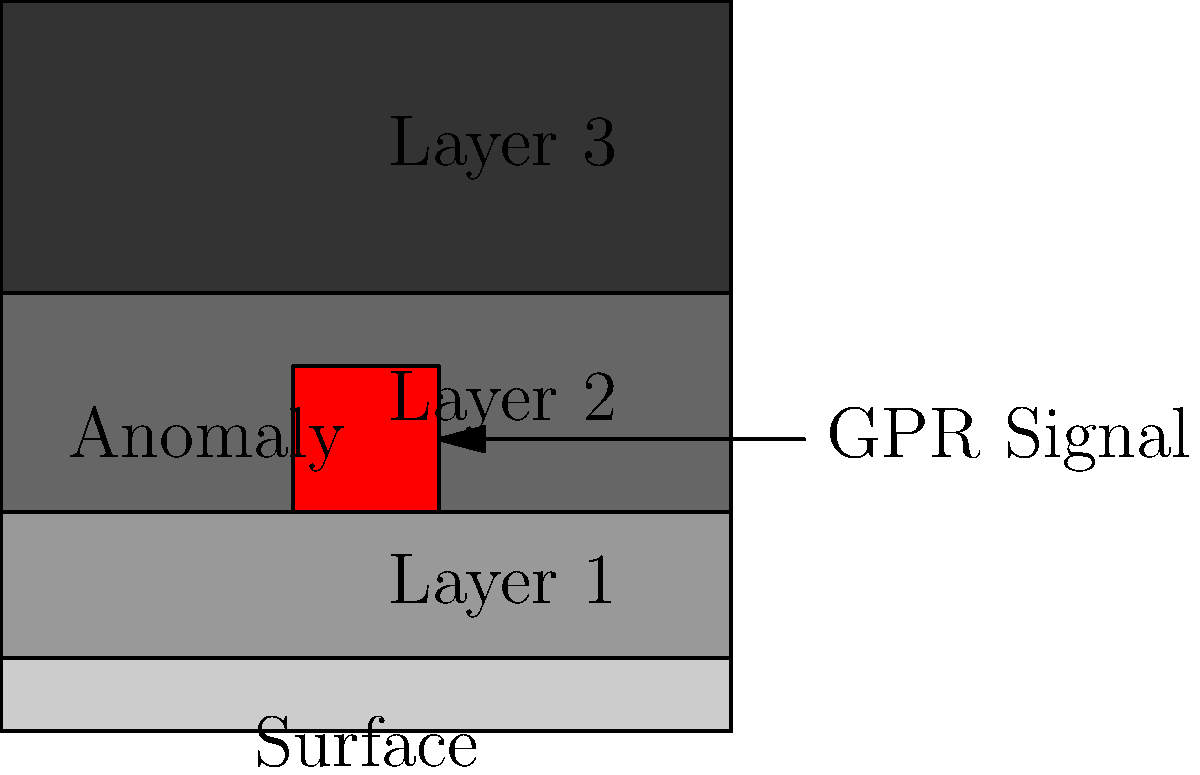In the given ground-penetrating radar (GPR) image, what does the red rectangular anomaly most likely represent, and in which layer is it located? To interpret this GPR image and answer the question, let's follow these steps:

1. Understand the image structure:
   - The image shows different layers of soil or sediment, represented by varying shades of gray.
   - Darker shades typically represent denser materials or different soil compositions.

2. Identify the layers:
   - The image shows four distinct layers, labeled from top to bottom as Surface, Layer 1, Layer 2, and Layer 3.

3. Locate the anomaly:
   - There is a red rectangular shape visible in the image, which represents an anomaly or a feature different from the surrounding material.

4. Determine the anomaly's position:
   - The red rectangle is primarily located within Layer 2, extending slightly into the bottom of Layer 1.

5. Interpret the anomaly:
   - In archaeological GPR surveys, rectangular anomalies often indicate human-made structures or features.
   - The sharp edges and regular shape suggest a solid, artificial structure rather than a natural geological formation.

6. Consider common archaeological features:
   - Given the context of archaeological contests, this anomaly likely represents a buried structure such as:
     a) A foundation wall
     b) A buried room or chamber
     c) A large stone block or slab
     d) A buried architectural feature

Conclusion: The red rectangular anomaly most likely represents a buried archaeological structure, such as a foundation wall or a buried room. It is primarily located in Layer 2 of the GPR image.
Answer: Buried archaeological structure in Layer 2 